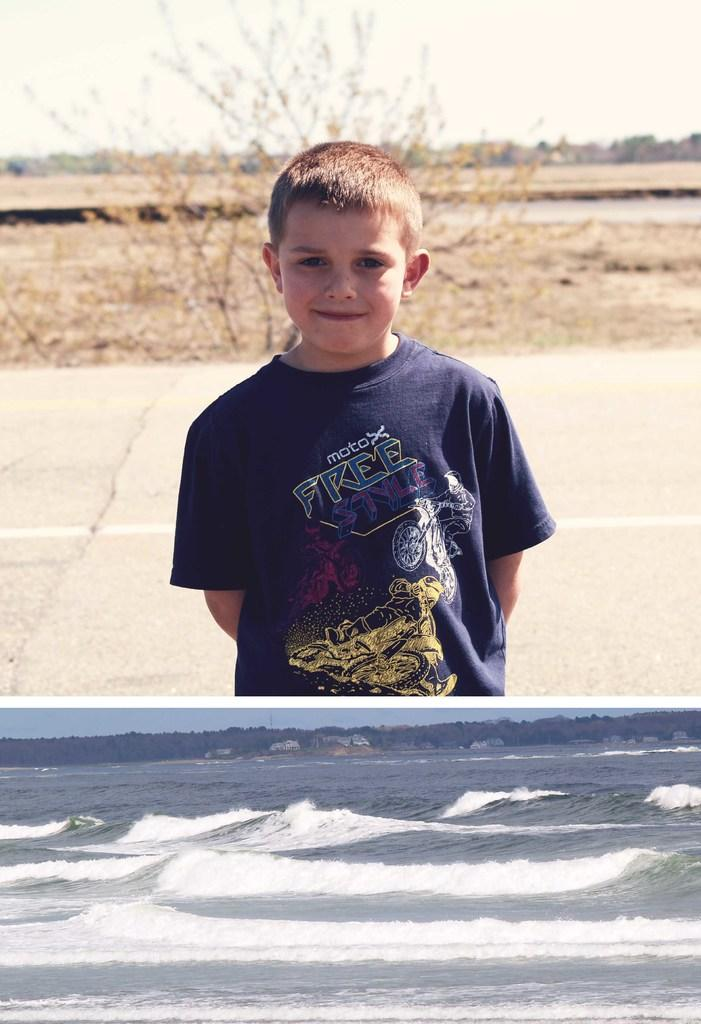What is the main feature of the image? There is a road in the image. Who or what can be seen on the road? A boy is standing on the road in the image. What is the boy wearing? The boy is wearing a blue color shirt. What else can be seen in the image besides the road and the boy? There are trees and the sky visible in the image. What theory does the boy have about the thread in the image? There is no thread present in the image, so the boy cannot have a theory about it. 